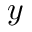<formula> <loc_0><loc_0><loc_500><loc_500>y</formula> 